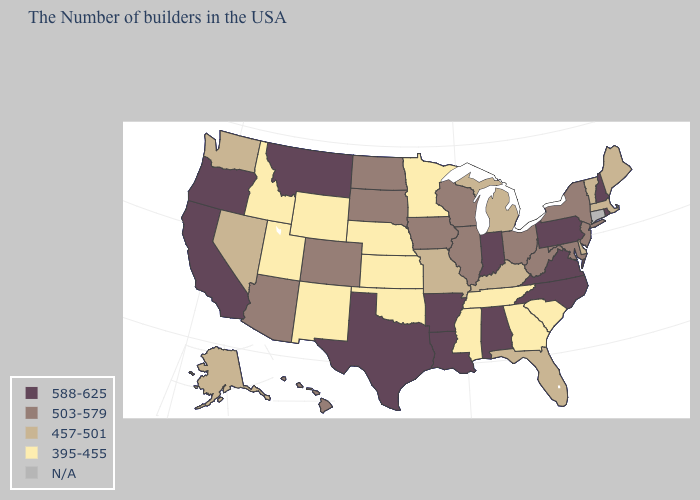Name the states that have a value in the range 588-625?
Concise answer only. Rhode Island, New Hampshire, Pennsylvania, Virginia, North Carolina, Indiana, Alabama, Louisiana, Arkansas, Texas, Montana, California, Oregon. Name the states that have a value in the range 588-625?
Answer briefly. Rhode Island, New Hampshire, Pennsylvania, Virginia, North Carolina, Indiana, Alabama, Louisiana, Arkansas, Texas, Montana, California, Oregon. What is the value of Oregon?
Give a very brief answer. 588-625. Name the states that have a value in the range 395-455?
Quick response, please. South Carolina, Georgia, Tennessee, Mississippi, Minnesota, Kansas, Nebraska, Oklahoma, Wyoming, New Mexico, Utah, Idaho. What is the value of Massachusetts?
Keep it brief. 457-501. What is the highest value in the USA?
Answer briefly. 588-625. What is the lowest value in the USA?
Write a very short answer. 395-455. Does Arkansas have the highest value in the South?
Be succinct. Yes. Does New Jersey have the highest value in the Northeast?
Be succinct. No. What is the value of West Virginia?
Short answer required. 503-579. What is the highest value in states that border Missouri?
Keep it brief. 588-625. Which states have the lowest value in the Northeast?
Short answer required. Maine, Massachusetts, Vermont. Name the states that have a value in the range N/A?
Give a very brief answer. Connecticut. 